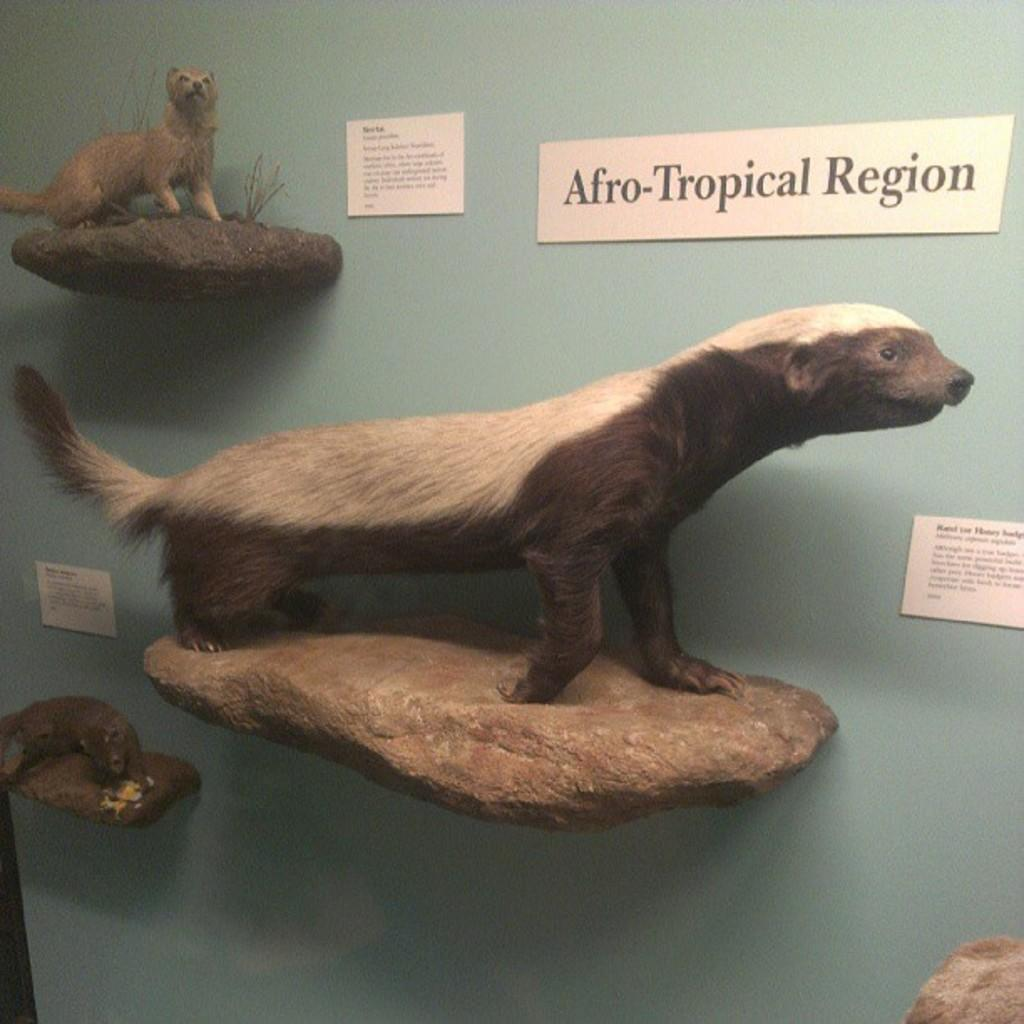What type of structure is present in the image? There is a wall in the image. What is attached to the wall? Stones are attached to the wall. What is depicted on the stones? Animal sculptures are present on the stones. What else can be seen on the wall? There are boards and labels visible on the wall. How many people are sitting on the chair in the image? There is no chair present in the image. What type of shake is being offered at the wall in the image? There is no shake or any food or beverage being offered in the image. 